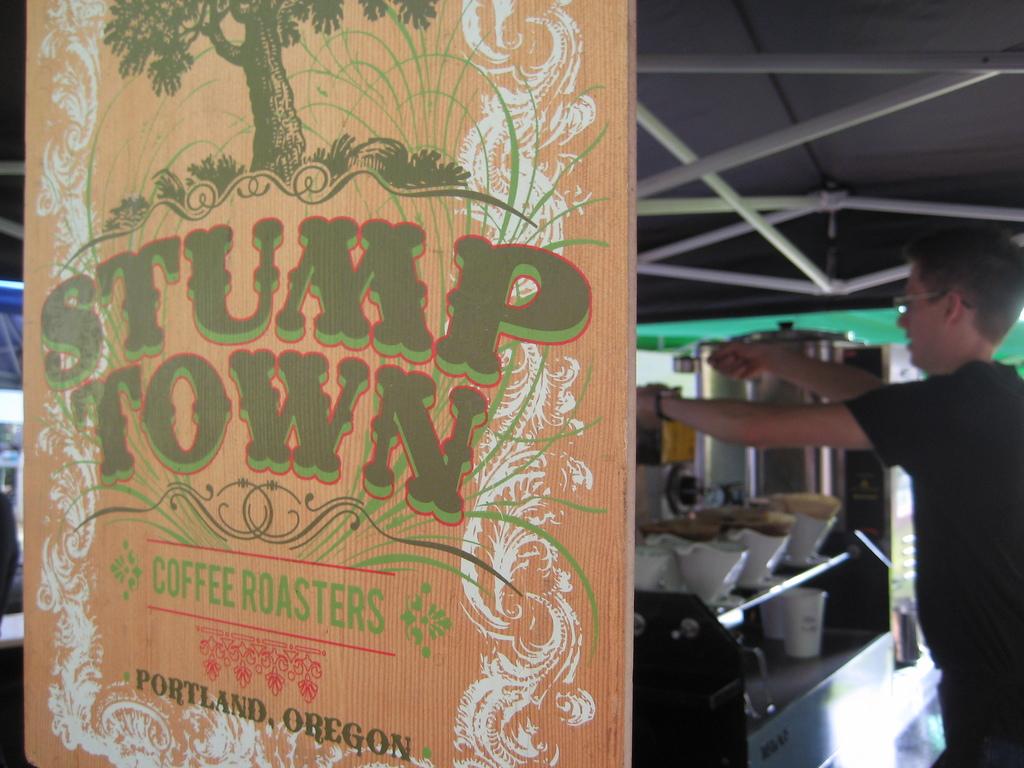What city is stump town coffee roasters from?
Ensure brevity in your answer.  Portland. Is this stump town?
Your response must be concise. Yes. 